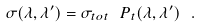<formula> <loc_0><loc_0><loc_500><loc_500>\sigma ( \lambda , \lambda ^ { \prime } ) = \sigma _ { t o t } \ P _ { t } ( \lambda , \lambda ^ { \prime } ) \ .</formula> 